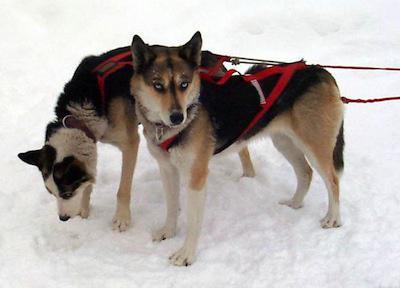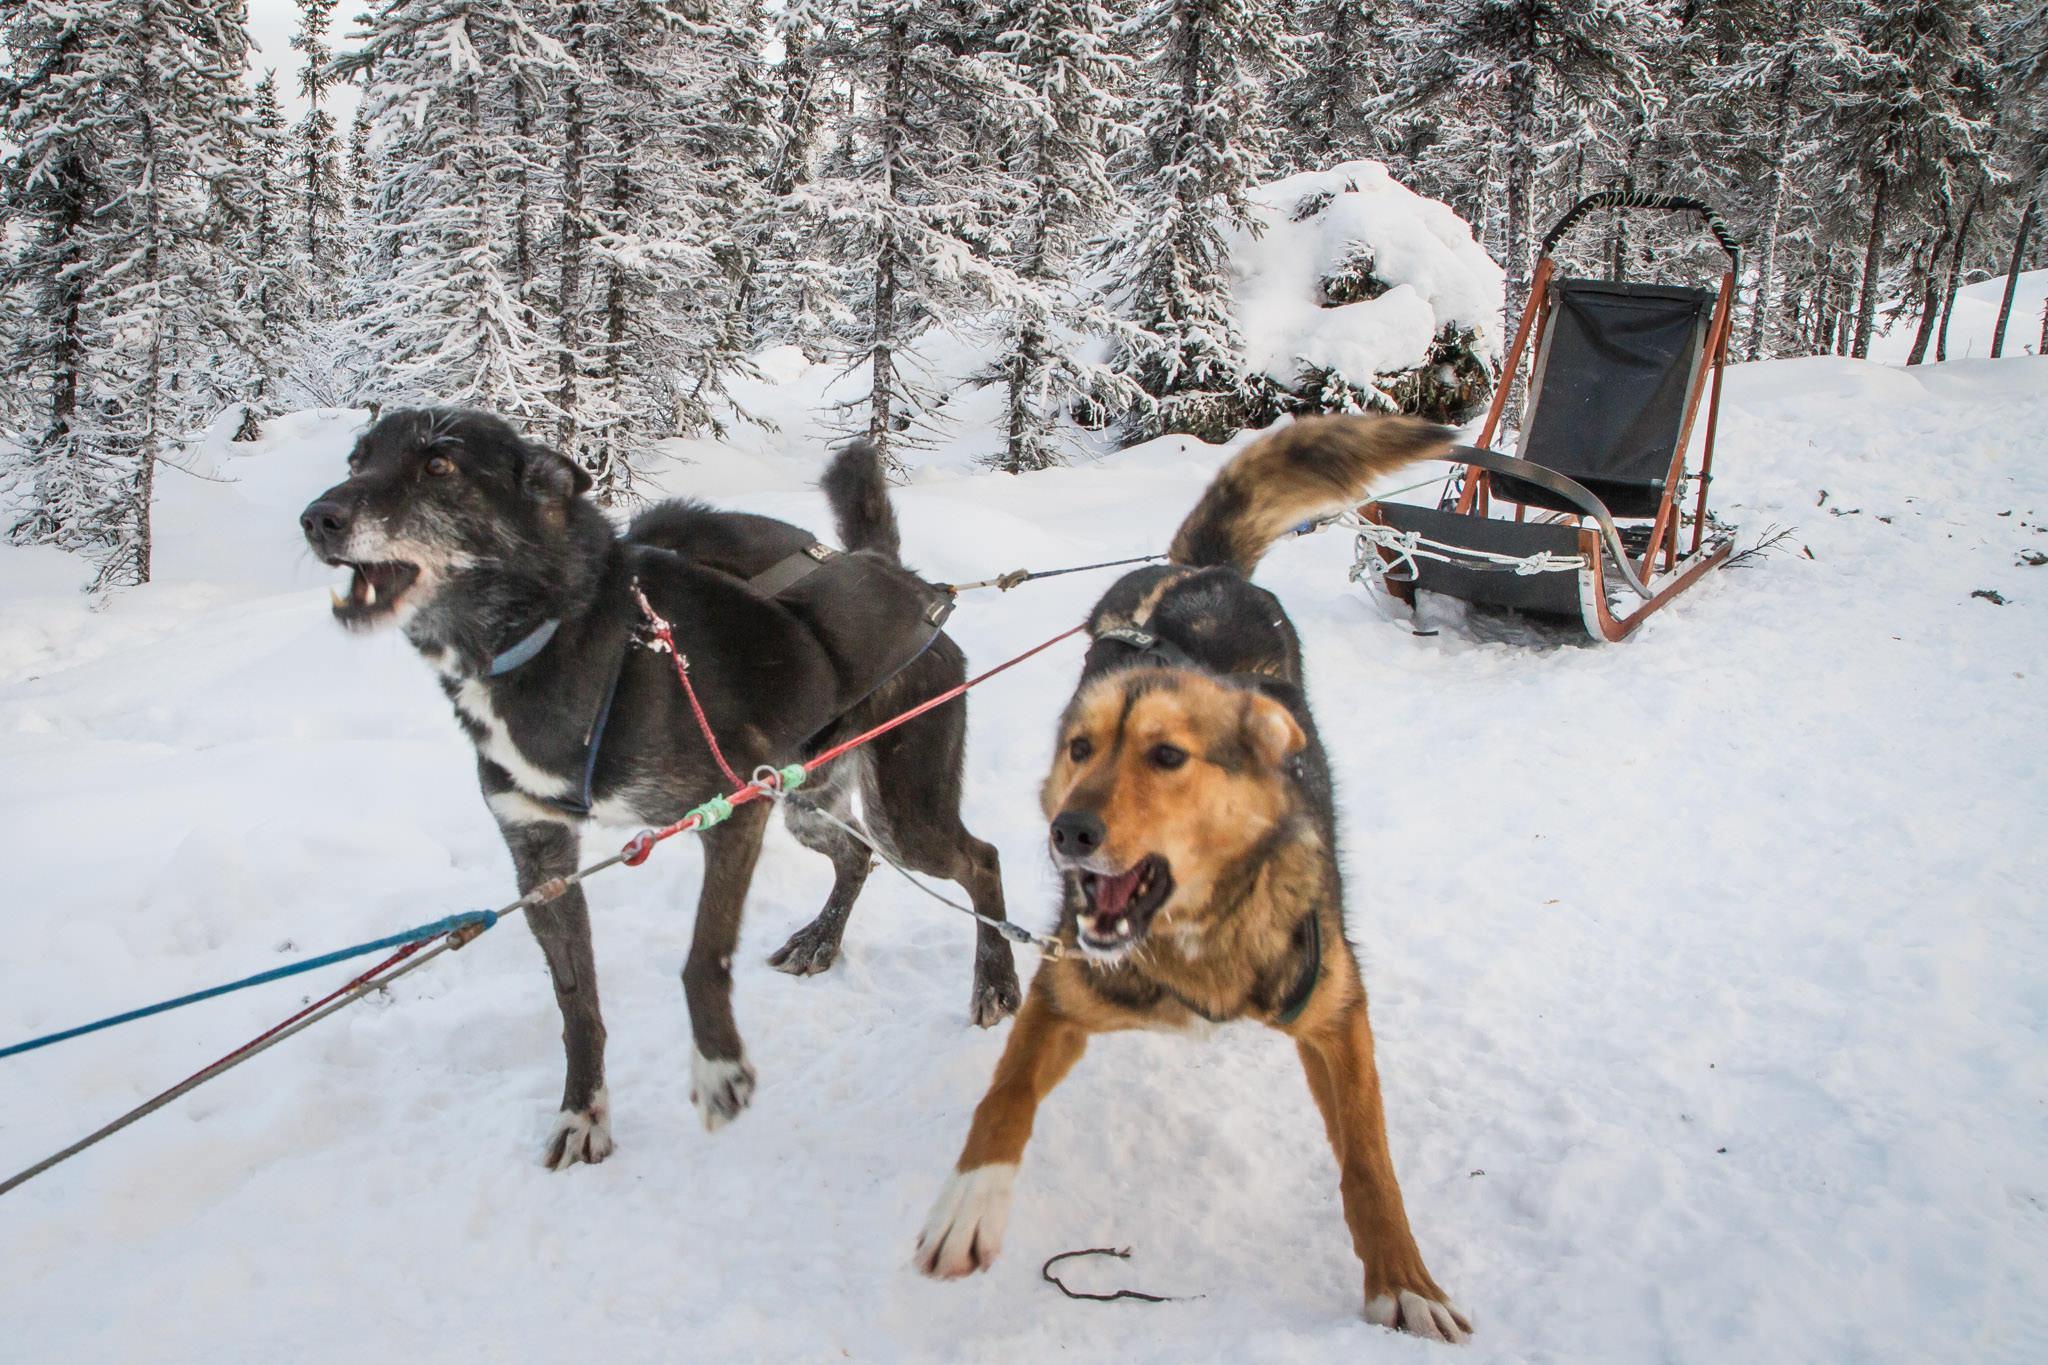The first image is the image on the left, the second image is the image on the right. For the images shown, is this caption "The left image contains no more than two sled dogs." true? Answer yes or no. Yes. The first image is the image on the left, the second image is the image on the right. For the images shown, is this caption "Two dogs are connected to reins in the image on the left." true? Answer yes or no. Yes. 